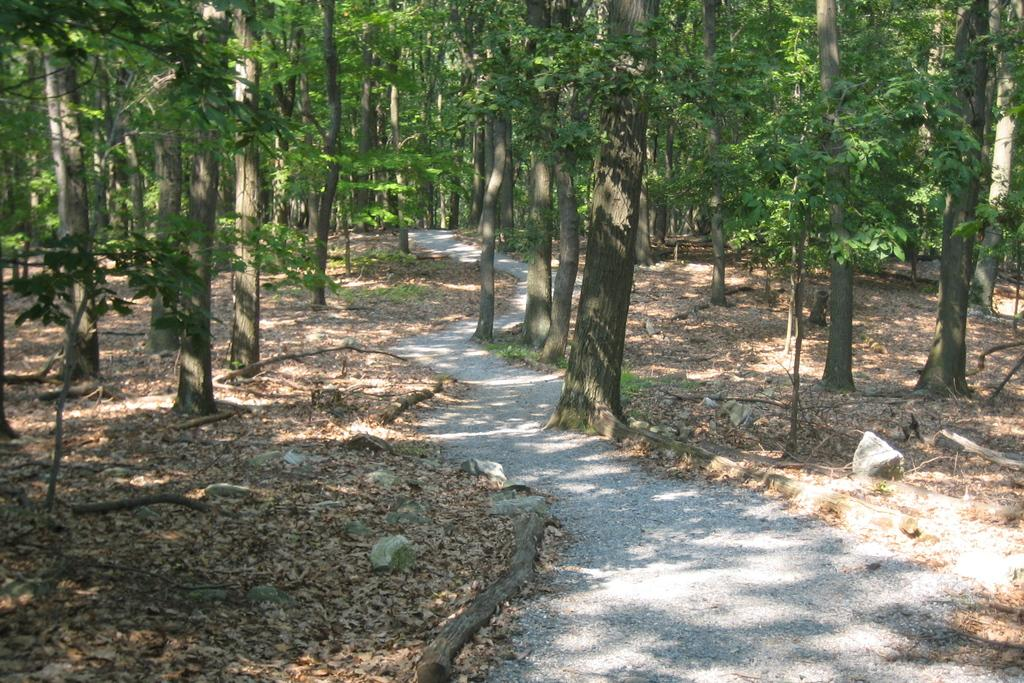What can be seen in the image that people might walk on? There is a pathway in the image that people might walk on. What is covering the pathway in the image? Dried leaves are present on the pathway in the image. What can be seen in the distance in the image? There are trees in the background of the image. What type of pie is being served by the grandmother in the image? There is no grandmother or pie present in the image. What can be used to write on the pencil in the image? There is no pencil present in the image. 